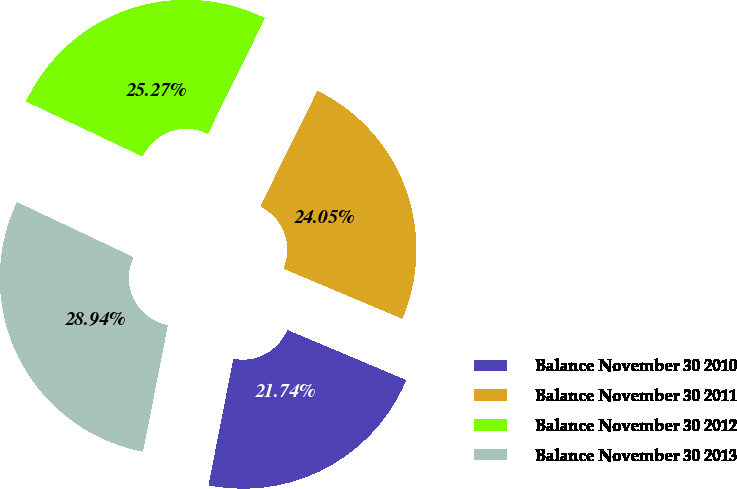Convert chart to OTSL. <chart><loc_0><loc_0><loc_500><loc_500><pie_chart><fcel>Balance November 30 2010<fcel>Balance November 30 2011<fcel>Balance November 30 2012<fcel>Balance November 30 2013<nl><fcel>21.74%<fcel>24.05%<fcel>25.27%<fcel>28.94%<nl></chart> 